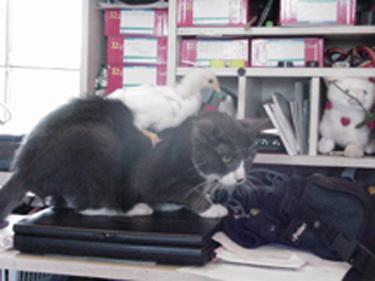Question: how many cats are there?
Choices:
A. Two.
B. Three.
C. Five.
D. One.
Answer with the letter. Answer: D Question: who is sitting on the laptop?
Choices:
A. Teddy bear.
B. Child.
C. Man.
D. Cat.
Answer with the letter. Answer: D 